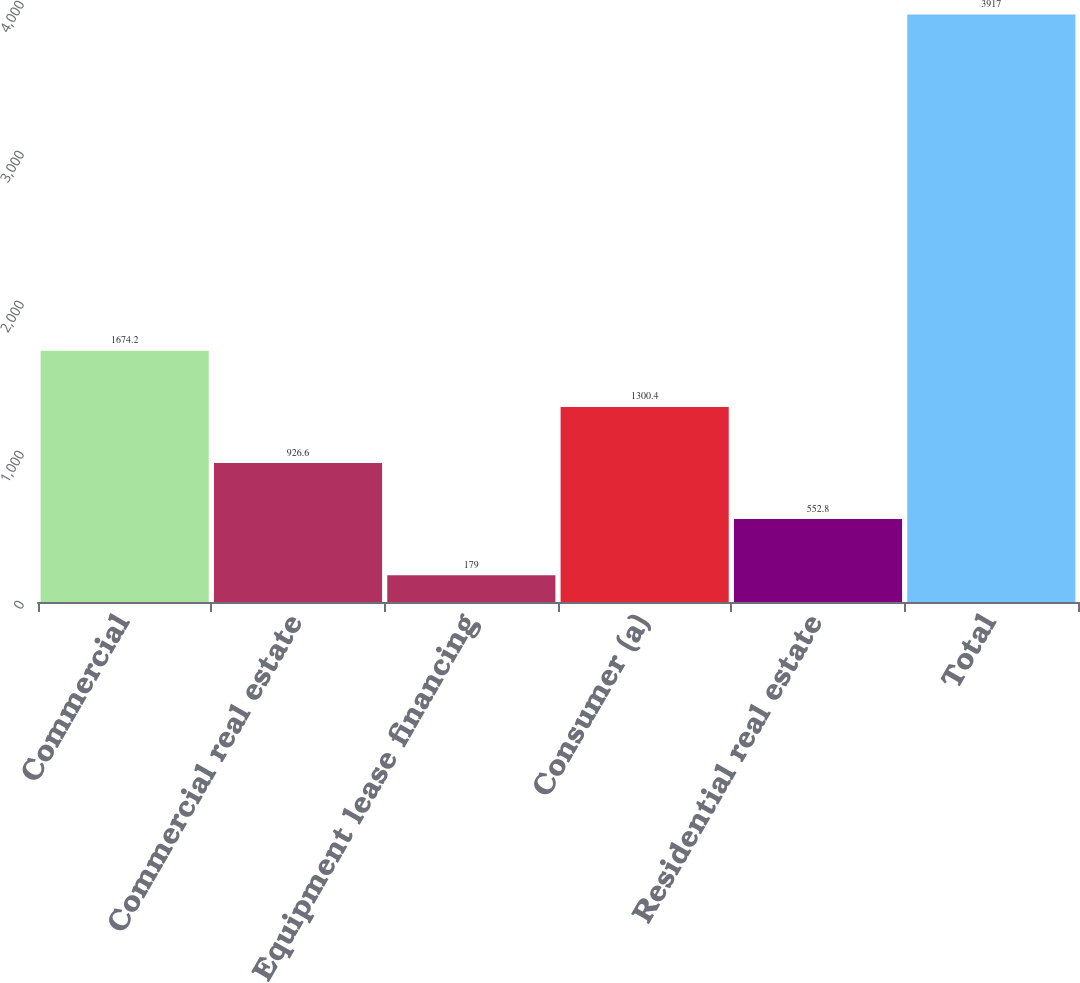Convert chart. <chart><loc_0><loc_0><loc_500><loc_500><bar_chart><fcel>Commercial<fcel>Commercial real estate<fcel>Equipment lease financing<fcel>Consumer (a)<fcel>Residential real estate<fcel>Total<nl><fcel>1674.2<fcel>926.6<fcel>179<fcel>1300.4<fcel>552.8<fcel>3917<nl></chart> 